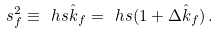<formula> <loc_0><loc_0><loc_500><loc_500>s _ { f } ^ { 2 } \equiv \ h s \hat { k } _ { f } = \ h s ( 1 + \Delta \hat { k } _ { f } ) \, .</formula> 